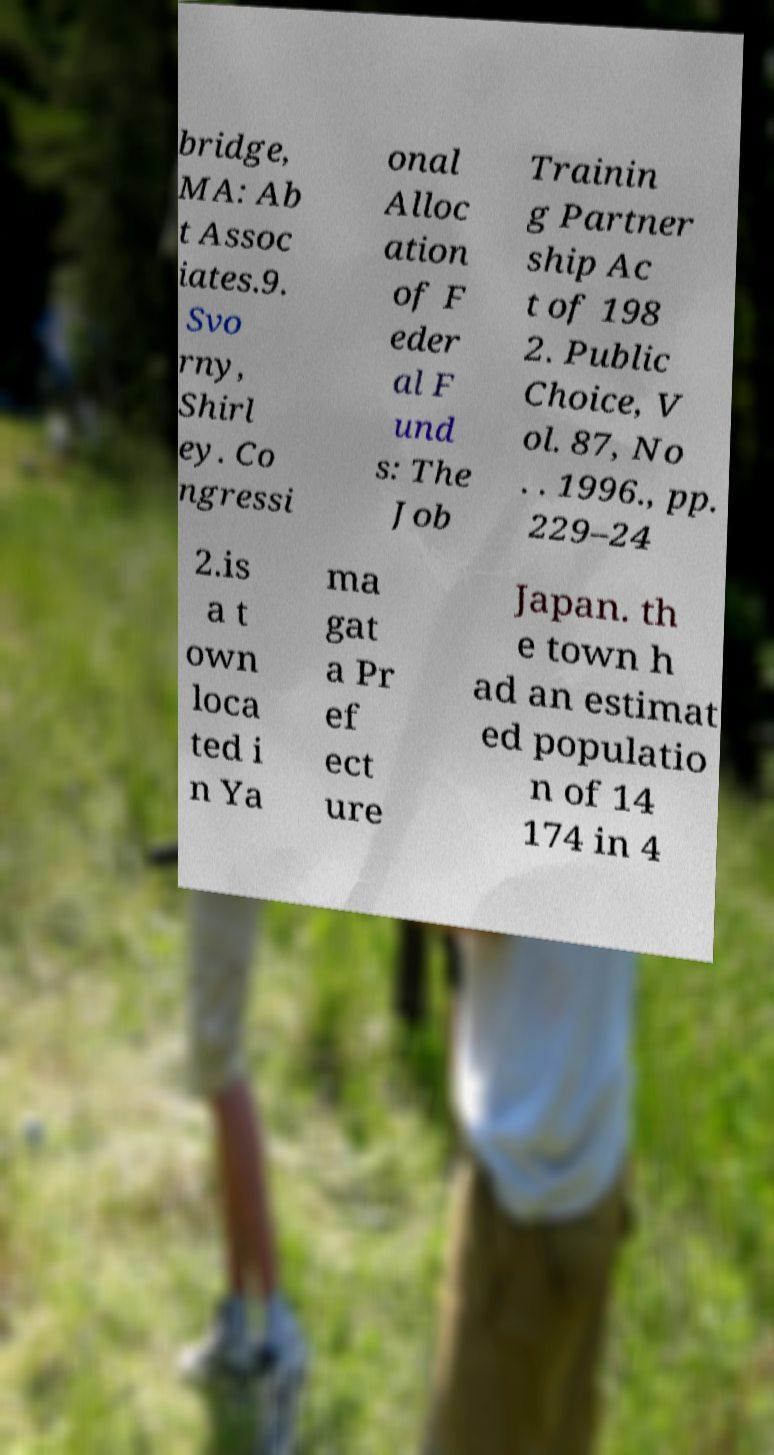For documentation purposes, I need the text within this image transcribed. Could you provide that? bridge, MA: Ab t Assoc iates.9. Svo rny, Shirl ey. Co ngressi onal Alloc ation of F eder al F und s: The Job Trainin g Partner ship Ac t of 198 2. Public Choice, V ol. 87, No . . 1996., pp. 229–24 2.is a t own loca ted i n Ya ma gat a Pr ef ect ure Japan. th e town h ad an estimat ed populatio n of 14 174 in 4 